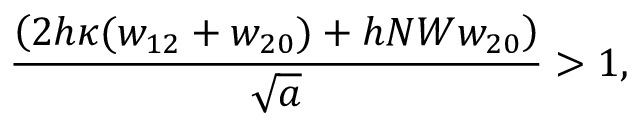<formula> <loc_0><loc_0><loc_500><loc_500>\frac { \left ( 2 h \kappa ( w _ { 1 2 } + w _ { 2 0 } ) + h N W w _ { 2 0 } \right ) } { \sqrt { a } } > 1 ,</formula> 